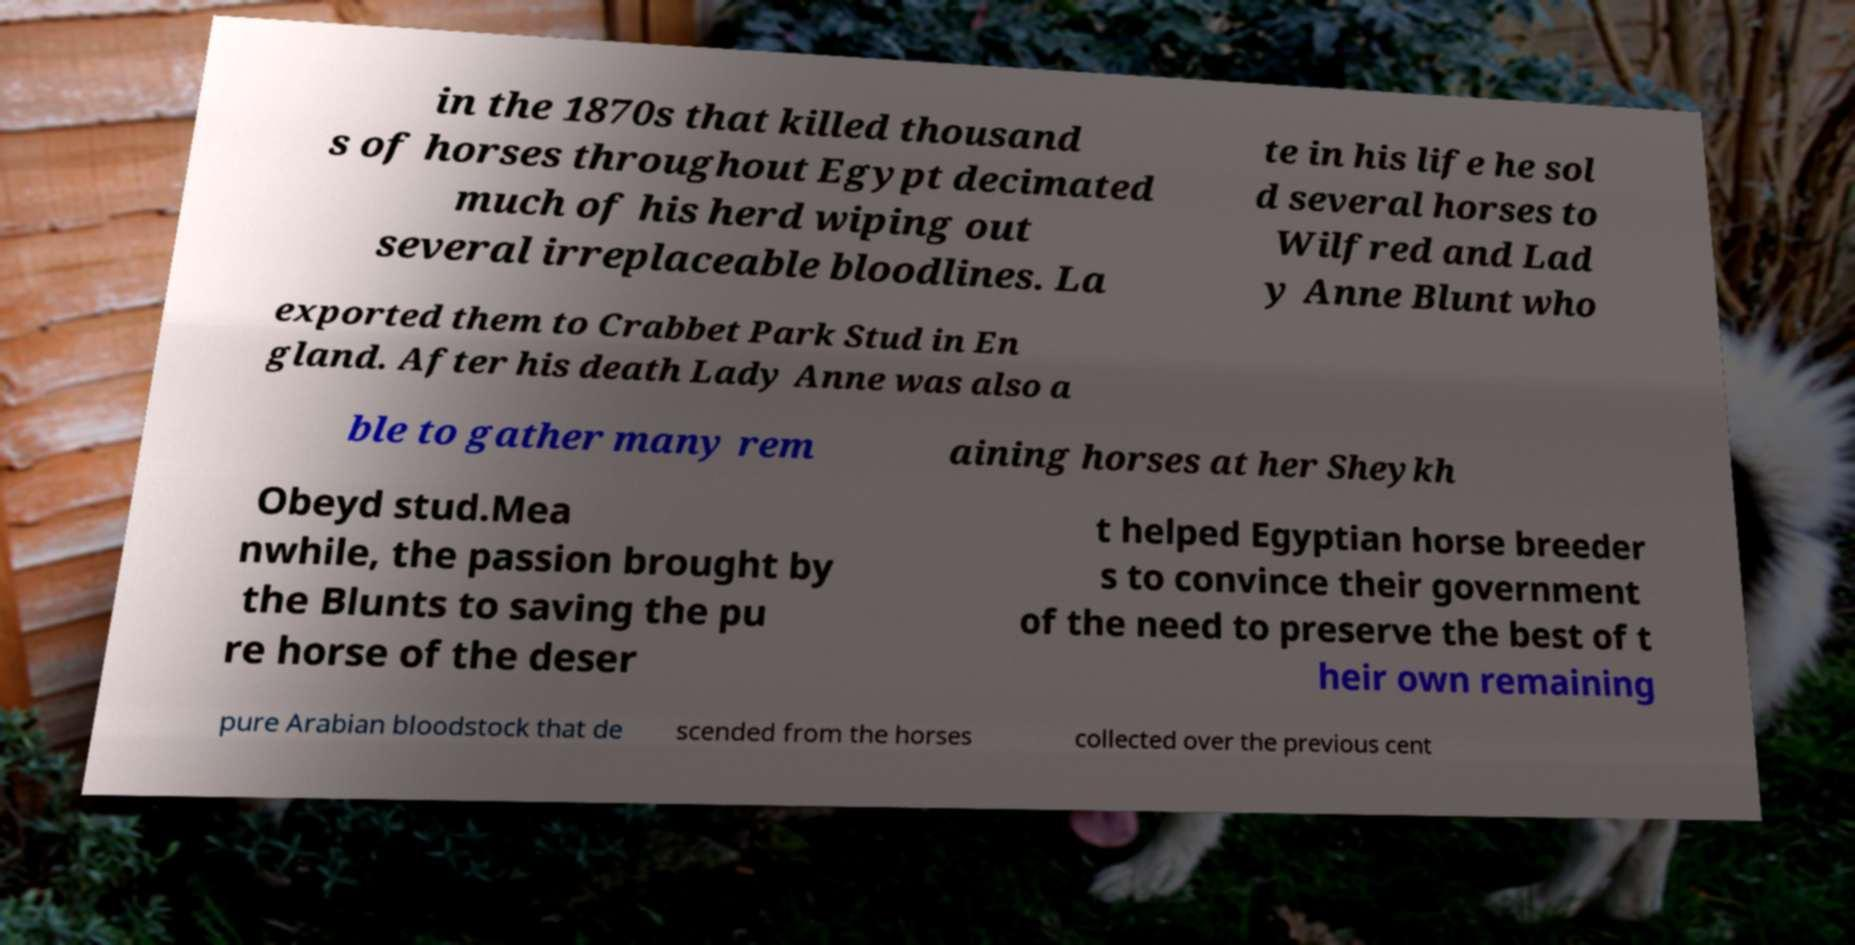I need the written content from this picture converted into text. Can you do that? in the 1870s that killed thousand s of horses throughout Egypt decimated much of his herd wiping out several irreplaceable bloodlines. La te in his life he sol d several horses to Wilfred and Lad y Anne Blunt who exported them to Crabbet Park Stud in En gland. After his death Lady Anne was also a ble to gather many rem aining horses at her Sheykh Obeyd stud.Mea nwhile, the passion brought by the Blunts to saving the pu re horse of the deser t helped Egyptian horse breeder s to convince their government of the need to preserve the best of t heir own remaining pure Arabian bloodstock that de scended from the horses collected over the previous cent 